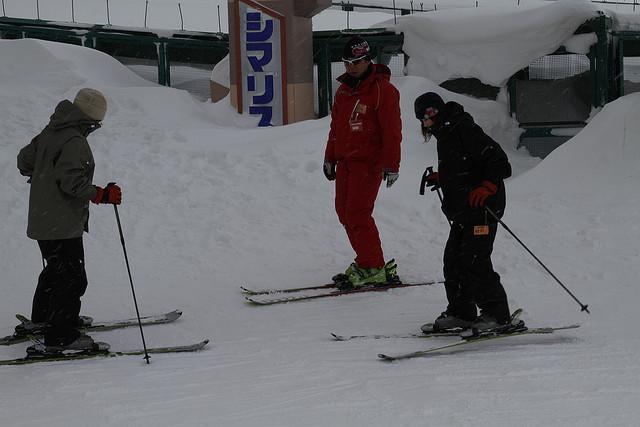How many people are in this photo?
Give a very brief answer. 3. How many skiers don't have poles?
Give a very brief answer. 1. How many people are skiing?
Give a very brief answer. 3. How many ski are in the photo?
Give a very brief answer. 2. How many people are there?
Give a very brief answer. 3. 